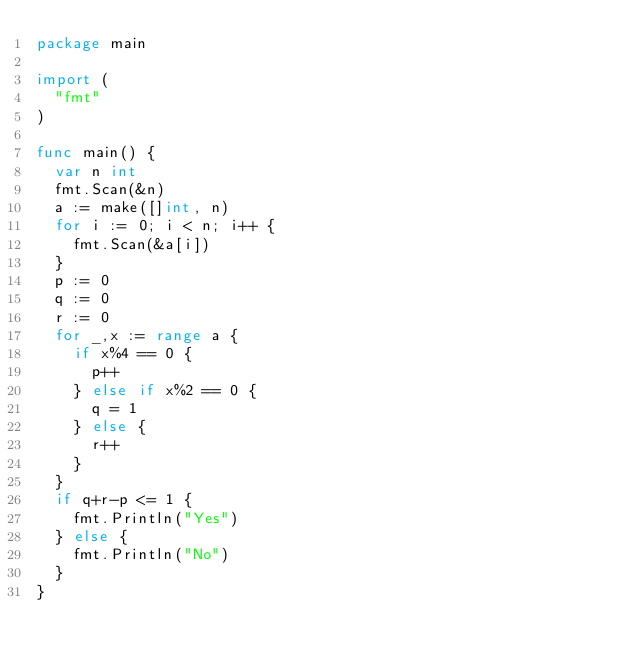<code> <loc_0><loc_0><loc_500><loc_500><_Go_>package main

import (
	"fmt"
)

func main() {
	var n int
	fmt.Scan(&n)
	a := make([]int, n)
	for i := 0; i < n; i++ {
		fmt.Scan(&a[i])
	}
	p := 0
	q := 0
	r := 0
	for _,x := range a {
		if x%4 == 0 {
			p++
		} else if x%2 == 0 {
			q = 1
		} else {
			r++
		}
	}
	if q+r-p <= 1 {
		fmt.Println("Yes")
	} else {
		fmt.Println("No")
	}
}
</code> 